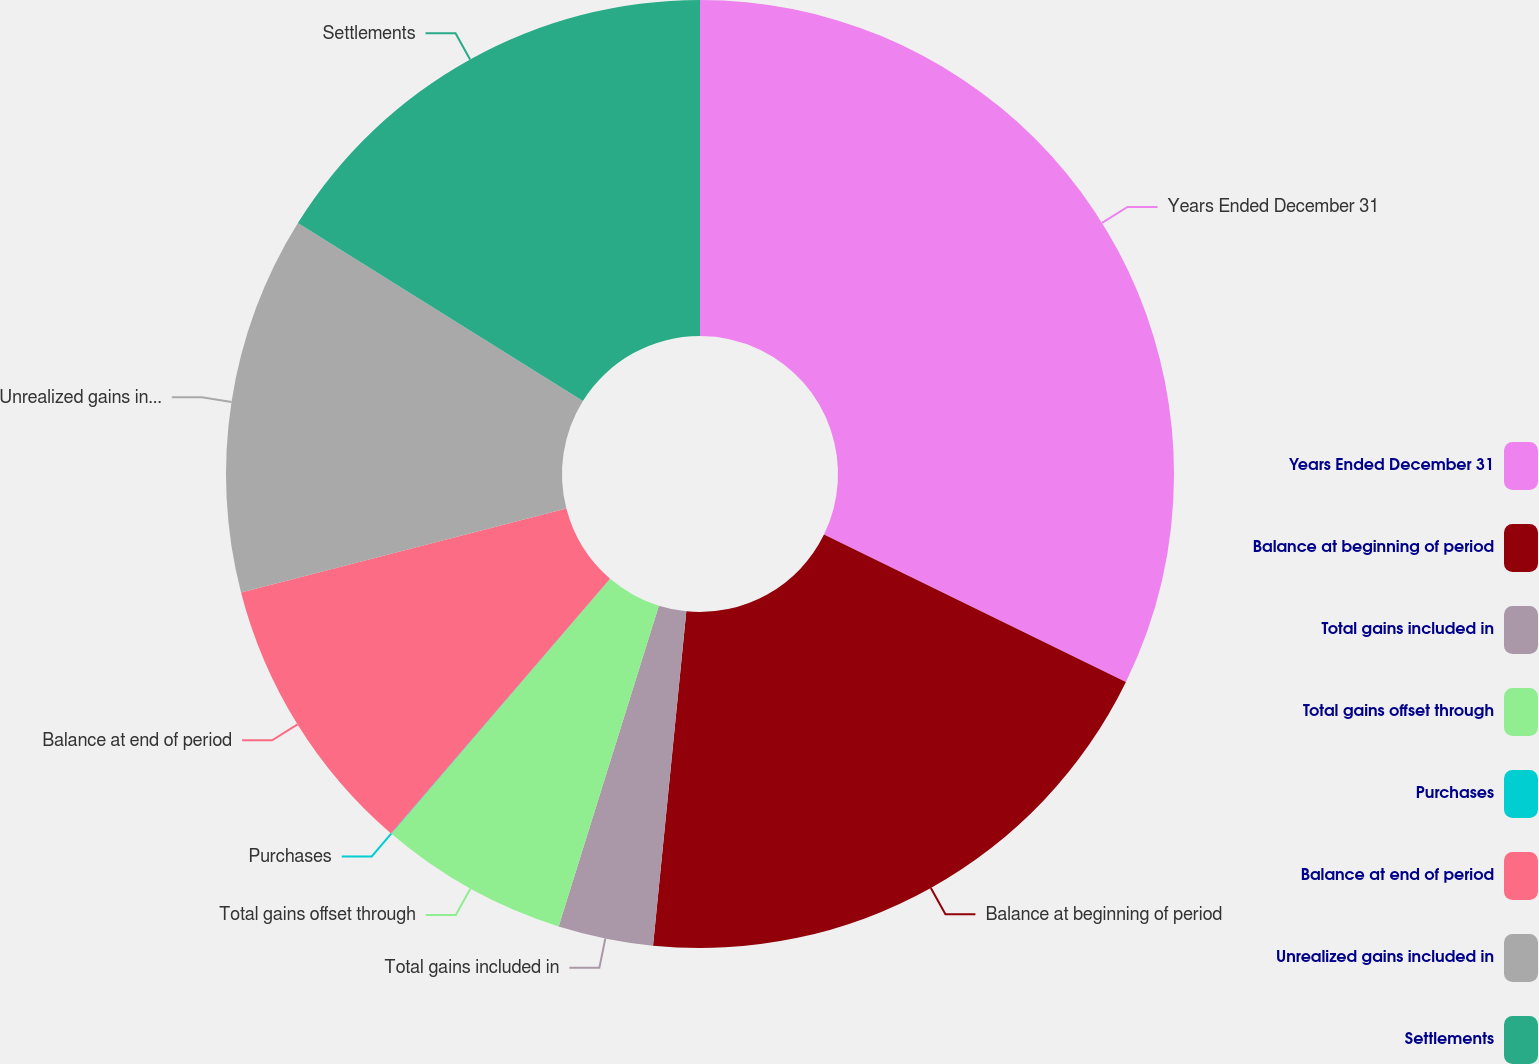Convert chart to OTSL. <chart><loc_0><loc_0><loc_500><loc_500><pie_chart><fcel>Years Ended December 31<fcel>Balance at beginning of period<fcel>Total gains included in<fcel>Total gains offset through<fcel>Purchases<fcel>Balance at end of period<fcel>Unrealized gains included in<fcel>Settlements<nl><fcel>32.23%<fcel>19.35%<fcel>3.24%<fcel>6.46%<fcel>0.02%<fcel>9.68%<fcel>12.9%<fcel>16.12%<nl></chart> 